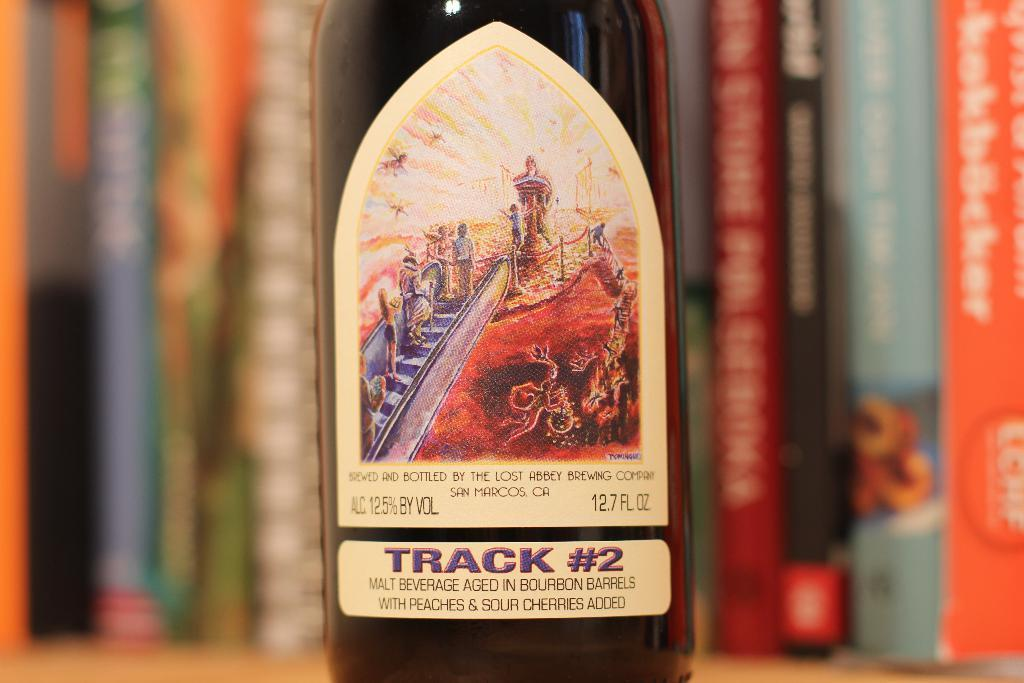<image>
Relay a brief, clear account of the picture shown. A bottle in front of books with the words Track number 2 underneath 